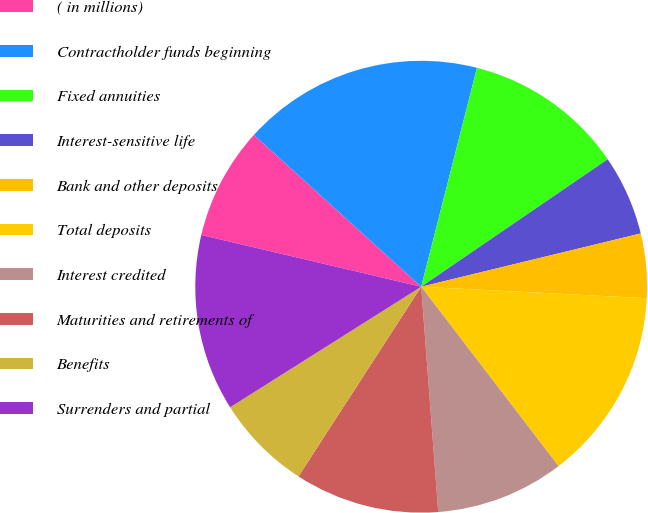<chart> <loc_0><loc_0><loc_500><loc_500><pie_chart><fcel>( in millions)<fcel>Contractholder funds beginning<fcel>Fixed annuities<fcel>Interest-sensitive life<fcel>Bank and other deposits<fcel>Total deposits<fcel>Interest credited<fcel>Maturities and retirements of<fcel>Benefits<fcel>Surrenders and partial<nl><fcel>8.05%<fcel>17.24%<fcel>11.49%<fcel>5.75%<fcel>4.6%<fcel>13.79%<fcel>9.2%<fcel>10.34%<fcel>6.9%<fcel>12.64%<nl></chart> 